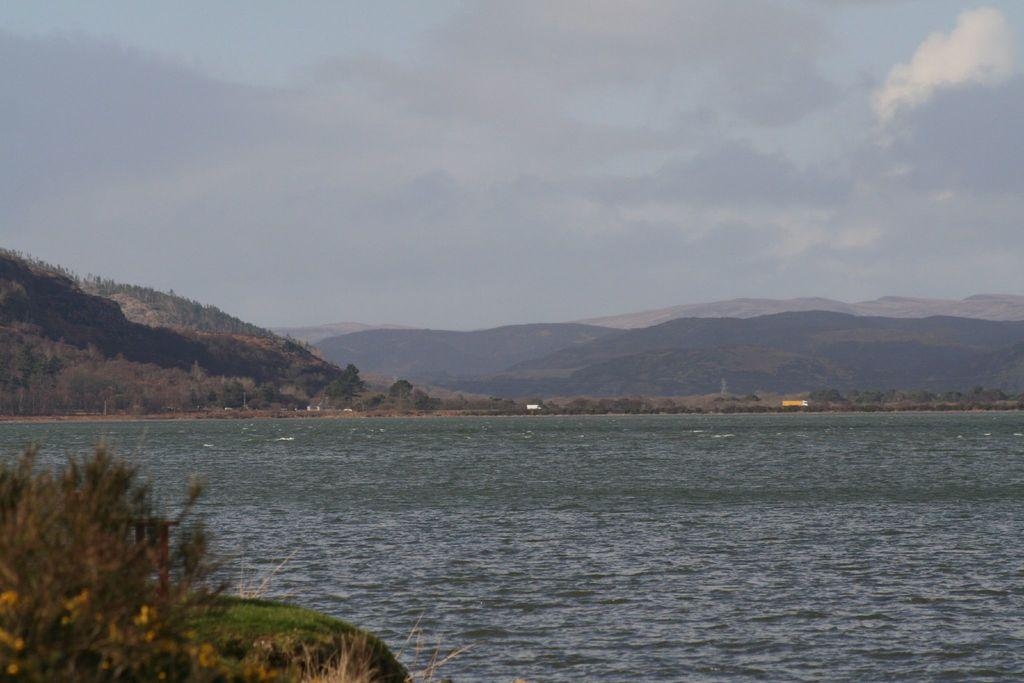What can be seen in the sky in the image? The sky with clouds is visible in the image. What type of natural landscape is present in the image? There are hills in the image. What mode of transportation can be seen in the image? Motor vehicles are present in the image. What body of water is visible in the image? There is a river in the image. What type of vegetation is present in the image? Plants are visible in the image. What direction is the minister walking in the image? There is no minister present in the image. What type of notebook is visible on the riverbank in the image? There is no notebook present in the image. 